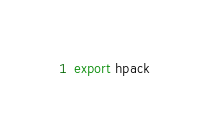Convert code to text. <code><loc_0><loc_0><loc_500><loc_500><_Nim_>
export hpack
</code> 